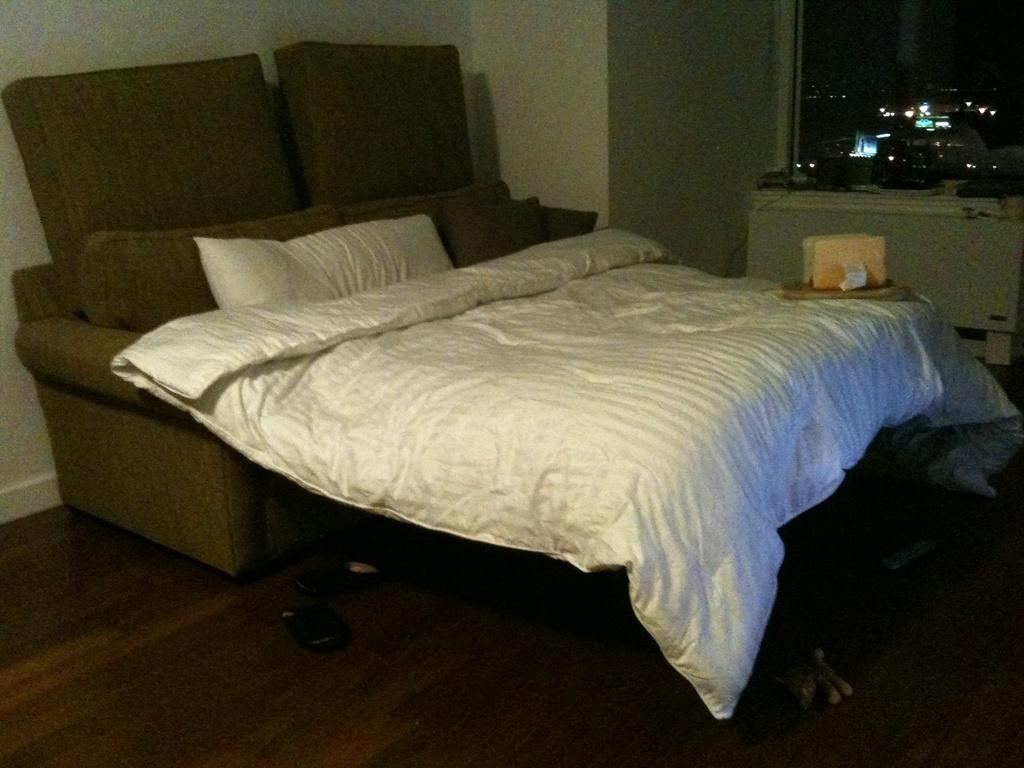What type of space is depicted in the image? There is a room in the image. What furniture is present in the room? There is a bed, a table, and wooden sticks on the floor in the room. What can be found on the bed? The bed has bed sheets and pillows. What architectural features can be seen in the room? There is a wall and a window in the room. What type of texture can be seen on the planes in the image? There are no planes present in the image; it features a room with a bed, table, and wooden sticks on the floor. Can you describe the zoo animals visible through the window in the image? There is no mention of a zoo or animals in the image; it only shows a room with a bed, table, and wooden sticks on the floor. 